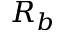Convert formula to latex. <formula><loc_0><loc_0><loc_500><loc_500>R _ { b }</formula> 